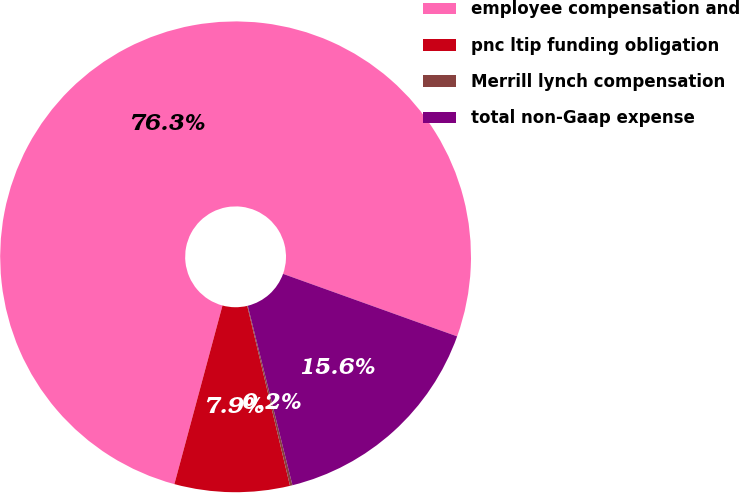Convert chart to OTSL. <chart><loc_0><loc_0><loc_500><loc_500><pie_chart><fcel>employee compensation and<fcel>pnc ltip funding obligation<fcel>Merrill lynch compensation<fcel>total non-Gaap expense<nl><fcel>76.3%<fcel>7.9%<fcel>0.17%<fcel>15.63%<nl></chart> 